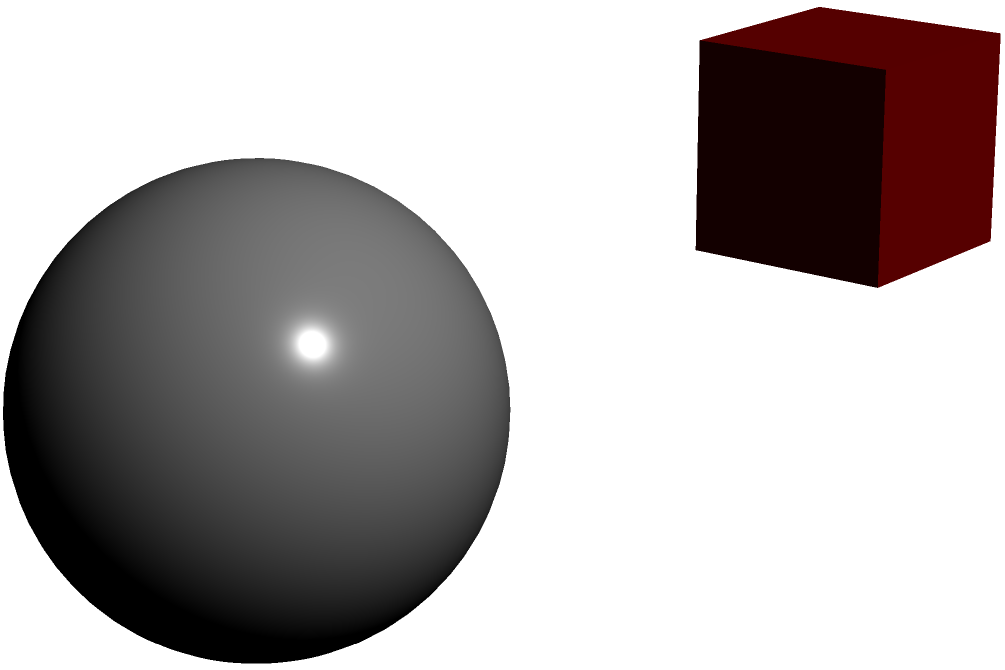As an aspiring sculptor looking to expand your artistic horizons, which of the materials represented above would you recommend for creating intricate, detailed sculptures with a smooth finish? Let's analyze each material represented in the image:

1. Clay (cube): 
   - Highly moldable and versatile
   - Can create smooth surfaces
   - Allows for intricate details
   - Easy to work with for beginners

2. Stone (sphere):
   - Durable and long-lasting
   - Requires significant skill to carve
   - Challenging to create intricate details
   - Difficult to achieve a smooth finish without extensive polishing

3. Metal (cone):
   - Can be cast or welded
   - Allows for smooth surfaces
   - Challenging to create intricate details by hand
   - Requires specialized tools and techniques

4. Wood (cylinder):
   - Natural material with unique grain patterns
   - Can be carved to create details
   - Achieving a perfectly smooth finish can be challenging
   - Grain may interfere with intricate designs

Considering the requirement for intricate, detailed sculptures with a smooth finish, clay stands out as the best option. It's highly moldable, allowing for the creation of complex shapes and fine details. Clay can also be smoothed easily to achieve a polished surface. Moreover, it's forgiving for beginners and encourages experimentation with new techniques, aligning with the persona of encouraging new artistic mediums.
Answer: Clay 